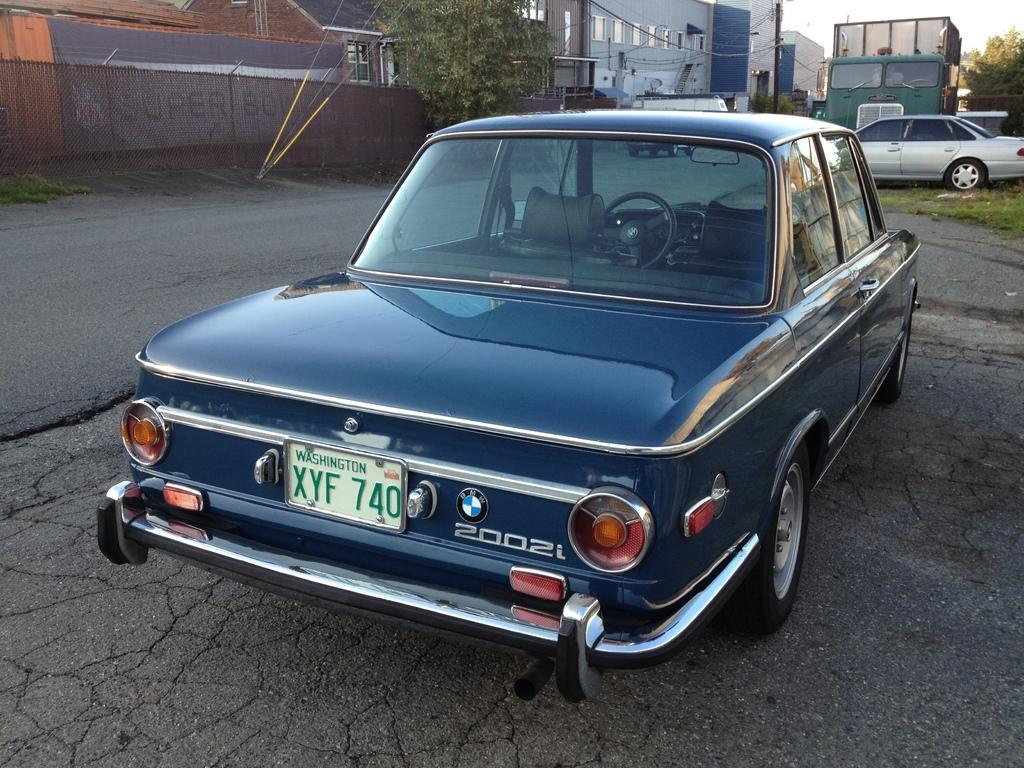What is the main feature of the image? There is a road in the image. What is on the road? A car is visible on the road. What can be seen in the distance? There are buildings, trees, wires, and other vehicles in the background of the image. What type of vegetation is present in the background? Grass is present in the background of the image. What type of partner is sitting next to the driver in the car? There is no indication of a partner or any passengers in the car in the image. 